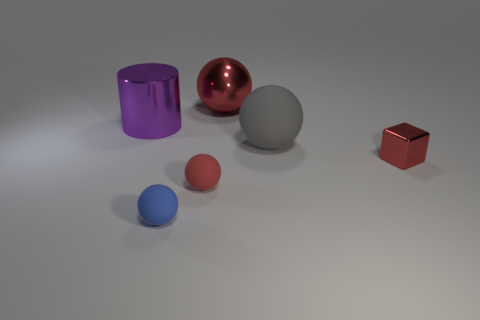What number of matte objects are small blue objects or large balls?
Give a very brief answer. 2. Does the cube have the same color as the metal sphere?
Your answer should be compact. Yes. There is a big red metallic ball; what number of balls are on the right side of it?
Your answer should be very brief. 1. How many things are both to the left of the big red ball and on the right side of the purple shiny thing?
Provide a succinct answer. 2. What shape is the small red thing that is made of the same material as the big purple cylinder?
Your answer should be very brief. Cube. Does the red metallic object on the left side of the gray ball have the same size as the red thing in front of the small cube?
Your response must be concise. No. There is a sphere that is behind the large gray object; what is its color?
Offer a terse response. Red. What material is the tiny ball that is in front of the tiny sphere that is on the right side of the small blue matte ball made of?
Offer a terse response. Rubber. The big purple metal object has what shape?
Make the answer very short. Cylinder. What material is the other big red thing that is the same shape as the red rubber object?
Offer a very short reply. Metal. 